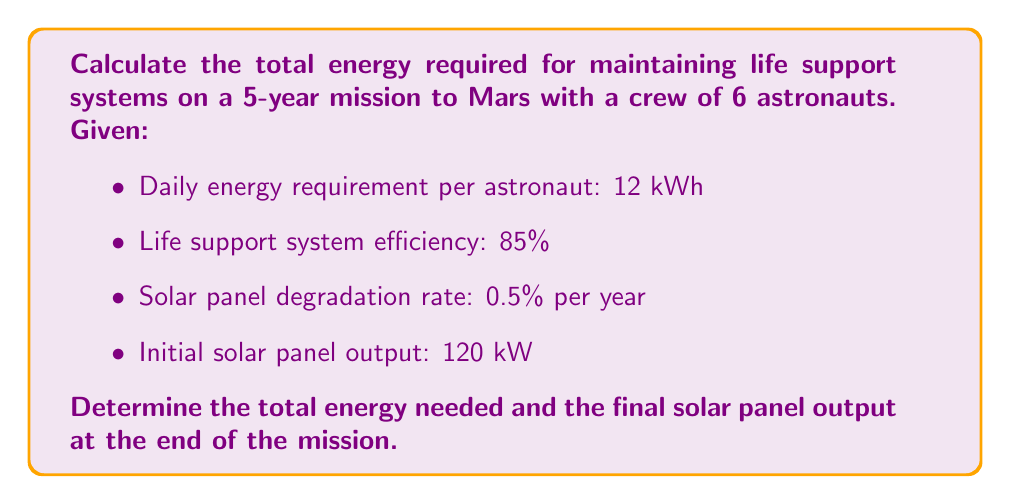What is the answer to this math problem? 1. Calculate the daily energy requirement for the entire crew:
   $$E_{daily} = 12 \text{ kWh} \times 6 \text{ astronauts} = 72 \text{ kWh}$$

2. Account for life support system efficiency:
   $$E_{actual} = \frac{E_{daily}}{0.85} = \frac{72}{0.85} = 84.71 \text{ kWh/day}$$

3. Calculate the total energy required for 5 years:
   $$E_{total} = E_{actual} \times 365 \text{ days} \times 5 \text{ years} = 84.71 \times 365 \times 5 = 154,595.75 \text{ kWh}$$

4. Calculate the solar panel degradation over 5 years:
   $$\text{Degradation} = 1 - (1 - 0.005)^5 = 1 - 0.9754 = 0.0246 \text{ or } 2.46\%$$

5. Calculate the final solar panel output:
   $$\text{Final output} = 120 \text{ kW} \times (1 - 0.0246) = 120 \times 0.9754 = 117.05 \text{ kW}$$
Answer: Total energy required: 154,595.75 kWh; Final solar panel output: 117.05 kW 